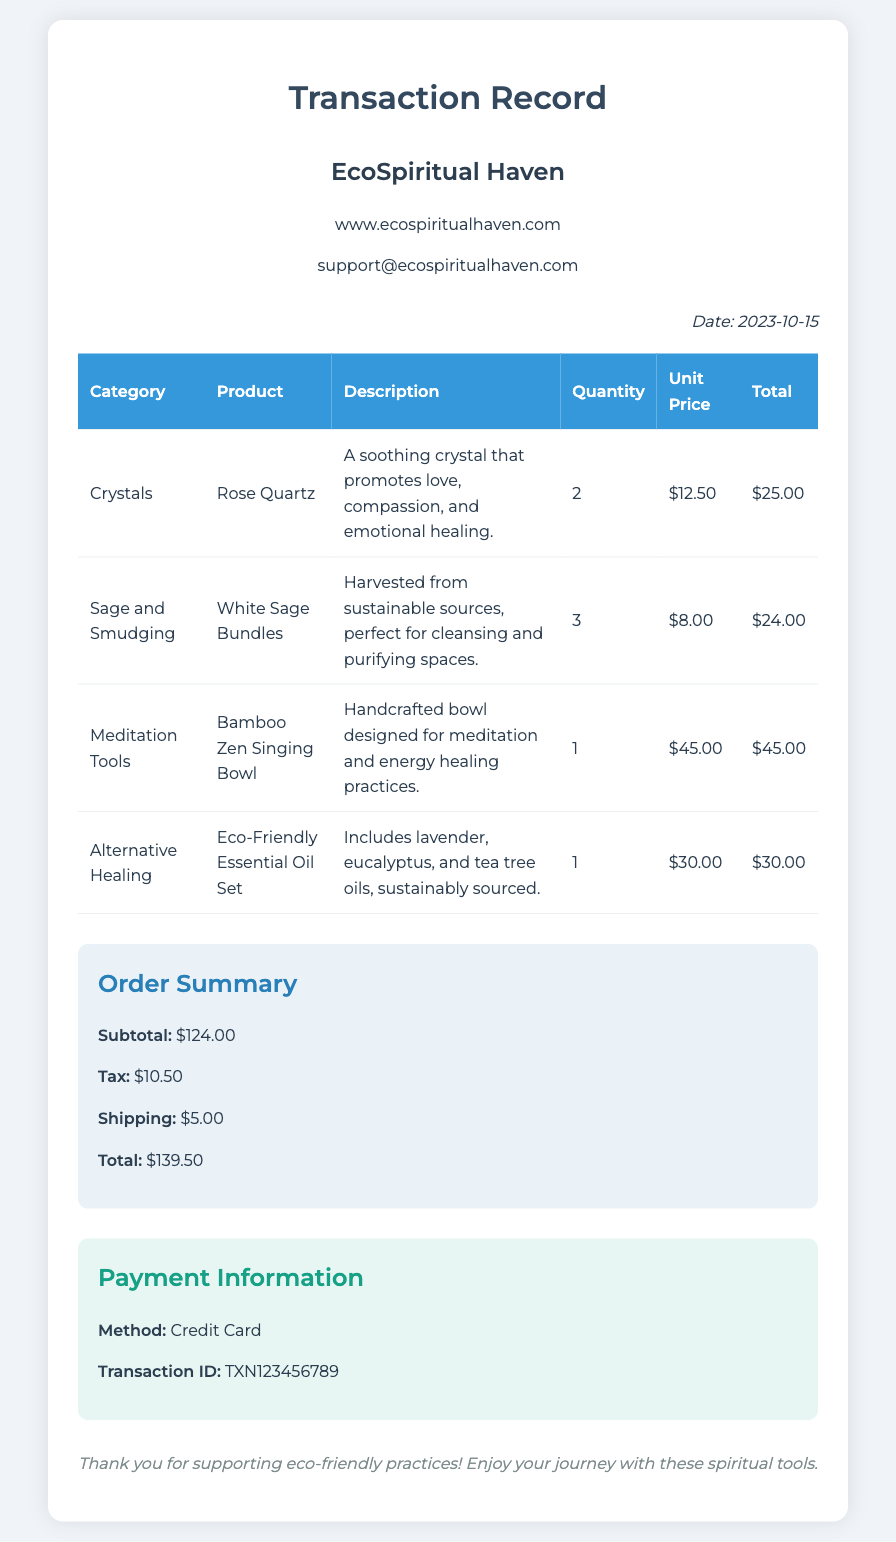What is the date of the transaction? The transaction date is specified in the document as the date of purchase.
Answer: 2023-10-15 How many Rose Quartz crystals were purchased? The quantity of Rose Quartz crystals bought is explicitly listed in the table under the respective product entry.
Answer: 2 What is the total cost of the White Sage Bundles? The total cost is calculated based on the unit price and quantity purchased, found in the transaction table.
Answer: $24.00 What is the subtotal for the entire order? The subtotal is the sum of all the product totals before tax and shipping, provided in the order summary details.
Answer: $124.00 What payment method was used for the transaction? The payment information section clearly states which method was used for the transaction.
Answer: Credit Card How much was charged for tax? The tax amount is detailed in the order summary section of the document.
Answer: $10.50 What is the transaction ID? The transaction ID is a unique identifier provided in the payment information section for this specific purchase.
Answer: TXN123456789 How many different categories are listed in the purchase? The number of unique categories can be counted based on the entries in the document.
Answer: 4 What is the total amount spent, including shipping? The document provides a total amount that includes all costs, calculated and presented in the order summary.
Answer: $139.50 